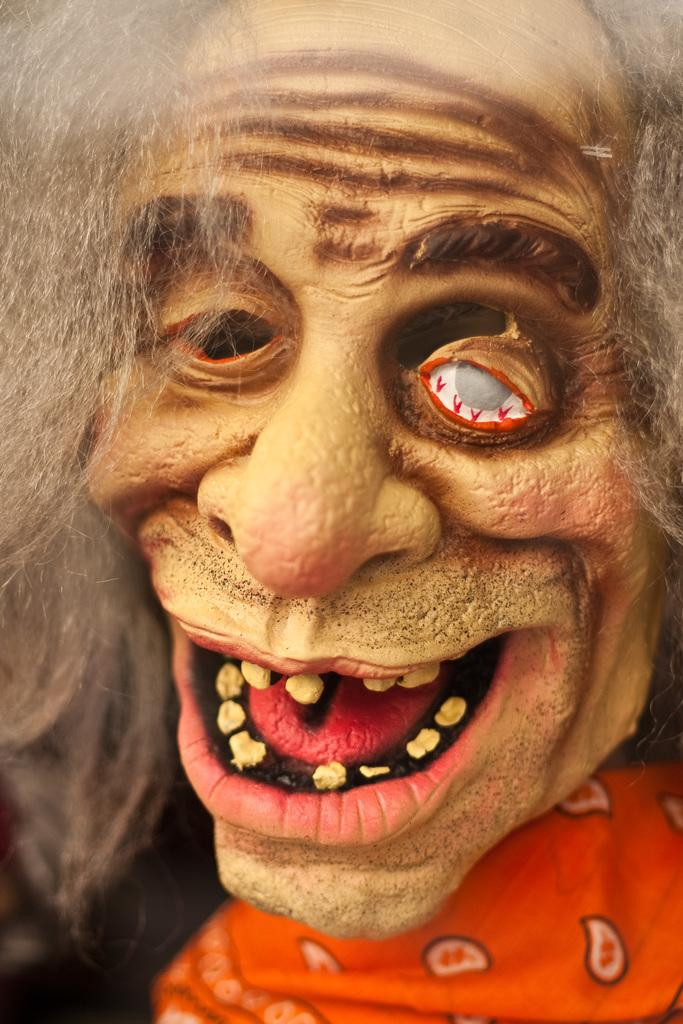What is the main subject of the picture? The main subject of the picture is a statue. Can you describe the statue in the picture? The statue is of an old man. How does the old man's appearance in the statue resemble a zombie? The old man's appearance in the statue resembles a zombie due to its decayed and decomposed features. What type of chair is the old man sitting on in the image? There is no chair present in the image, as the old man is a statue. What example of regret can be seen in the image? There is no example of regret depicted in the image, as it only features a statue of an old man resembling a zombie. 